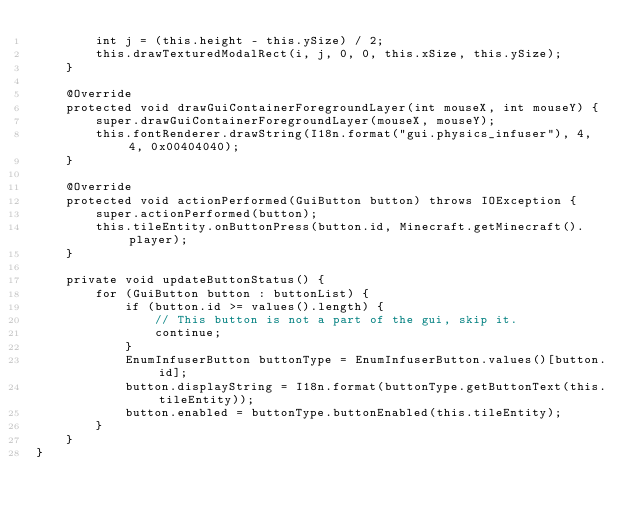Convert code to text. <code><loc_0><loc_0><loc_500><loc_500><_Java_>        int j = (this.height - this.ySize) / 2;
        this.drawTexturedModalRect(i, j, 0, 0, this.xSize, this.ySize);
    }

    @Override
    protected void drawGuiContainerForegroundLayer(int mouseX, int mouseY) {
        super.drawGuiContainerForegroundLayer(mouseX, mouseY);
        this.fontRenderer.drawString(I18n.format("gui.physics_infuser"), 4, 4, 0x00404040);
    }

    @Override
    protected void actionPerformed(GuiButton button) throws IOException {
        super.actionPerformed(button);
        this.tileEntity.onButtonPress(button.id, Minecraft.getMinecraft().player);
    }

    private void updateButtonStatus() {
        for (GuiButton button : buttonList) {
            if (button.id >= values().length) {
                // This button is not a part of the gui, skip it.
                continue;
            }
            EnumInfuserButton buttonType = EnumInfuserButton.values()[button.id];
            button.displayString = I18n.format(buttonType.getButtonText(this.tileEntity));
            button.enabled = buttonType.buttonEnabled(this.tileEntity);
        }
    }
}
</code> 